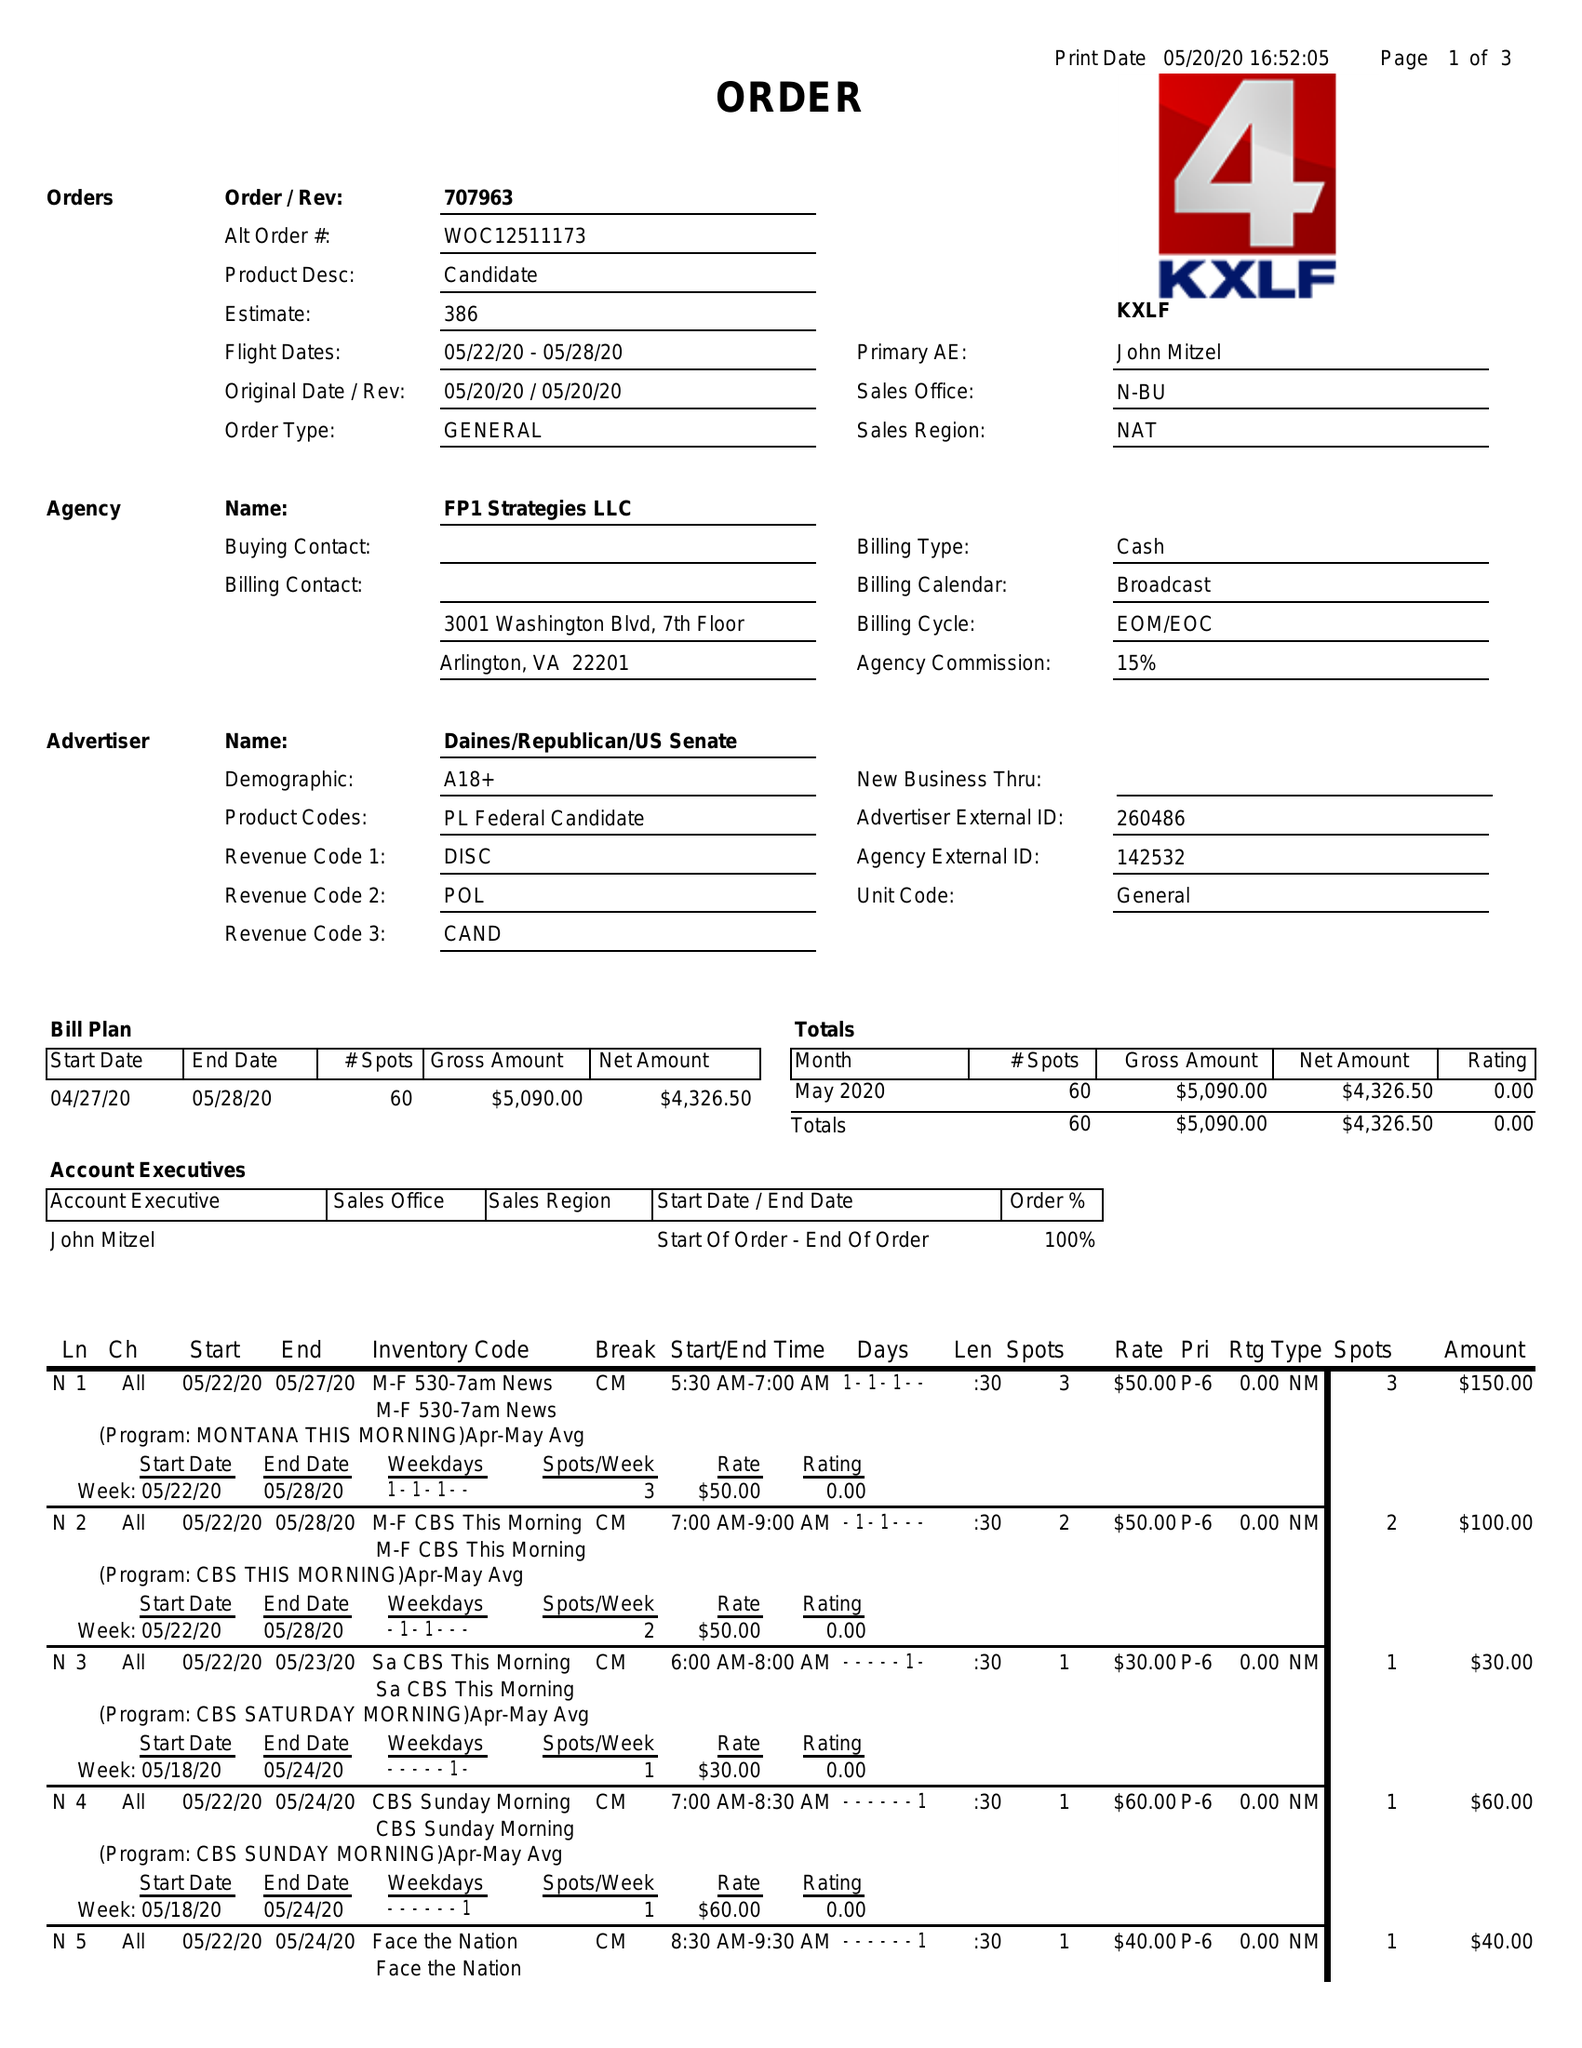What is the value for the flight_to?
Answer the question using a single word or phrase. 05/28/20 